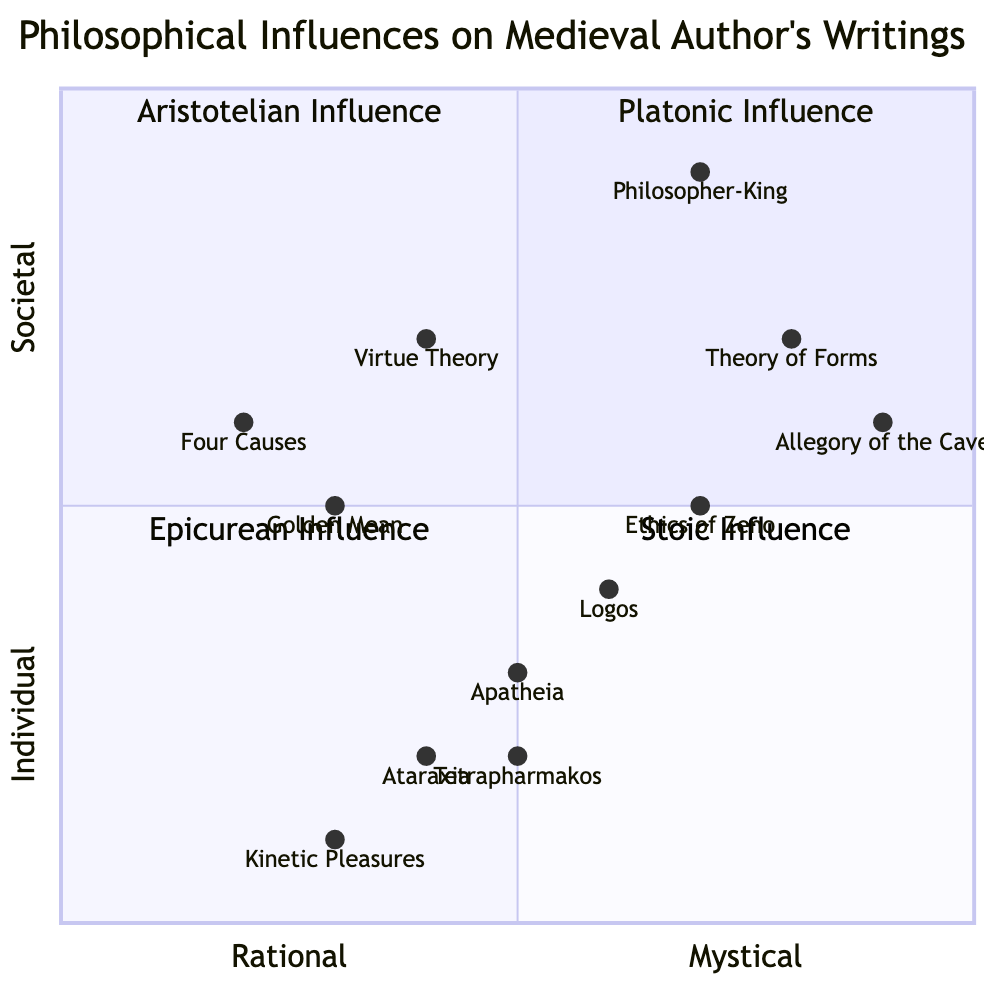What are the philosophical influences depicted in the first quadrant? The first quadrant is labeled "Platonic Influence." It includes elements such as the Theory of Forms, Allegory of the Cave, and Doctrine of the Philosopher-King.
Answer: Platonic Influence What is the y-axis label in the diagram? The y-axis represents the spectrum from Individual to Societal, indicating how the philosophical influences relate to individual thought versus collective societal thought.
Answer: Individual to Societal Which element in the Stoic Influence quadrant has the highest y-coordinate? The Ethics of Zeno is located at the coordinates [0.7, 0.5], which is the highest point compared to the other elements in the Stoic quadrant.
Answer: Ethics of Zeno How many elements are in the Aristotelian Influence quadrant? The Aristotelian Influence quadrant contains three elements: Golden Mean, Four Causes, and Ethics and Virtue Theory. Counting these gives a total of three elements.
Answer: 3 Which quadrant does the element "Ataraxia" belong to? Ataraxia is listed under the Epicurean Influence quadrant, which focuses on aspects of happiness and sensory experience.
Answer: Epicurean Influence What is the relationship between "Theory of Forms" and "Apatheia" in terms of rationality? The Theory of Forms has a rational positioning of 0.8. In contrast, Apatheia has a rational positioning of 0.5. This indicates that the Theory of Forms is more rational than Apatheia.
Answer: More Rational Which quadrant has elements that predominantly emphasize societal concepts? The Platonic Influence quadrant, as its elements discuss ideal states and the Philosopher-King concept, which are more aligned with societal structures and governance.
Answer: Platonic Influence What is the x-coordinate of the element "Kinetic Pleasures"? The coordinates for Kinetic Pleasures are [0.3, 0.1], with 0.3 being its x-coordinate.
Answer: 0.3 Which two quadrants represent influences focused more on individual thoughts and actions? The Epicurean Influence and Stoic Influence quadrants both emphasize personal happiness and self-control, making them more aligned with individual thought and actions.
Answer: Epicurean Influence and Stoic Influence 